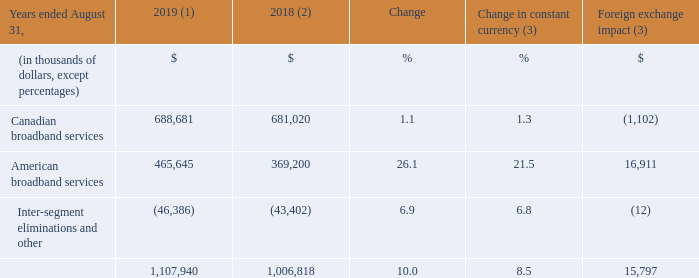ADJUSTED EBITDA
(1) Fiscal 2019 average foreign exchange rate used for translation was 1.3255 USD/CDN.
(2) Fiscal 2018 was restated to comply with IFRS 15 and to reflect a change in accounting policy as well as to reclassify results from Cogeco Peer 1 as discontinued operations. For further details, please consult the "Accounting policies" and "Discontinued operations" sections.
(3) Fiscal 2019 actuals are translated at the average foreign exchange rate of fiscal 2018 which was 1.2773 USD/CDN.
Fiscal 2019 adjusted EBITDA increased by 10.0% (8.5% in constant currency) as a result of: • an increase in the American broadband services segment mainly as a result of strong organic growth combined with the impact of the MetroCast and FiberLight acquisitions; and • an increase in the Canadian broadband services segment resulting mainly from a decline in operating expenses.
For further details on the Corporation’s adjusted EBITDA, please refer to the "Segmented operating and financial results" section.
What was the exchange rate in 2019? 1.3255 usd/cdn. What was the exchange rate in 2018? 1.2773 usd/cdn. What was the increase in 2019 EBITDA? 10.0%. What was the increase / (decrease) in Canadian broadband services from 2018 to 2019?
Answer scale should be: thousand. 688,681 - 681,020
Answer: 7661. What was the average American broadband services between 2018 and 2019?
Answer scale should be: thousand. (465,645 + 369,200) / 2
Answer: 417422.5. What was the increase / (decrease) in the Inter-segment eliminations and other from 2018 to 2019?
Answer scale should be: thousand. (-46,386) - (-43,402)
Answer: -2984. 